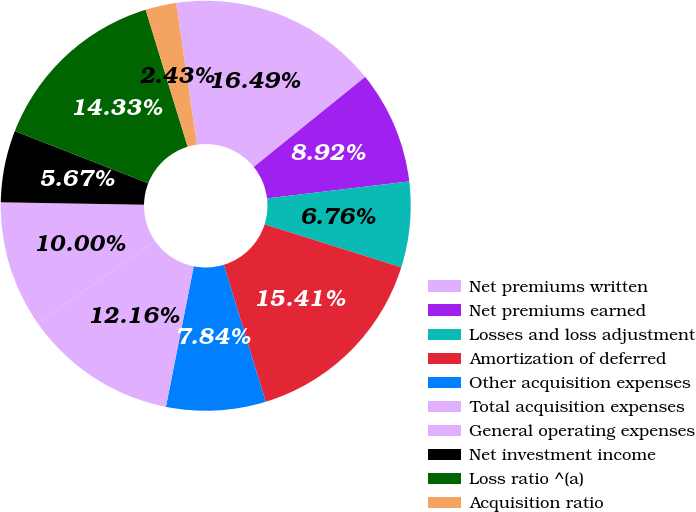Convert chart. <chart><loc_0><loc_0><loc_500><loc_500><pie_chart><fcel>Net premiums written<fcel>Net premiums earned<fcel>Losses and loss adjustment<fcel>Amortization of deferred<fcel>Other acquisition expenses<fcel>Total acquisition expenses<fcel>General operating expenses<fcel>Net investment income<fcel>Loss ratio ^(a)<fcel>Acquisition ratio<nl><fcel>16.49%<fcel>8.92%<fcel>6.76%<fcel>15.41%<fcel>7.84%<fcel>12.16%<fcel>10.0%<fcel>5.67%<fcel>14.33%<fcel>2.43%<nl></chart> 